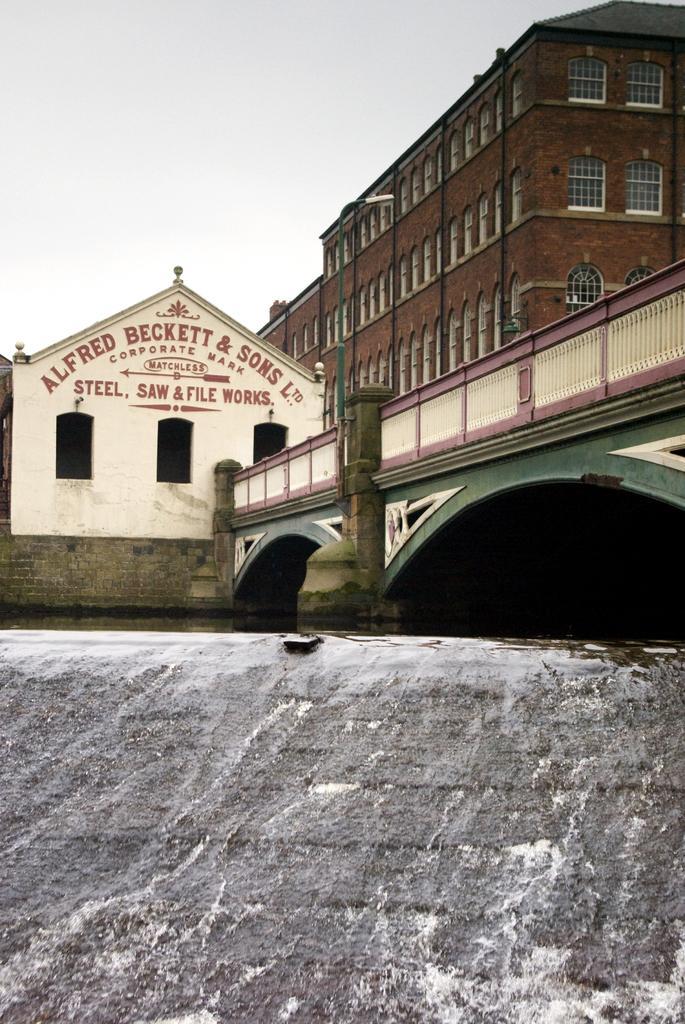In one or two sentences, can you explain what this image depicts? In this image there is wall. Behind the wall there are buildings and a bridge. There is text on a building. At the top there is the sky. 